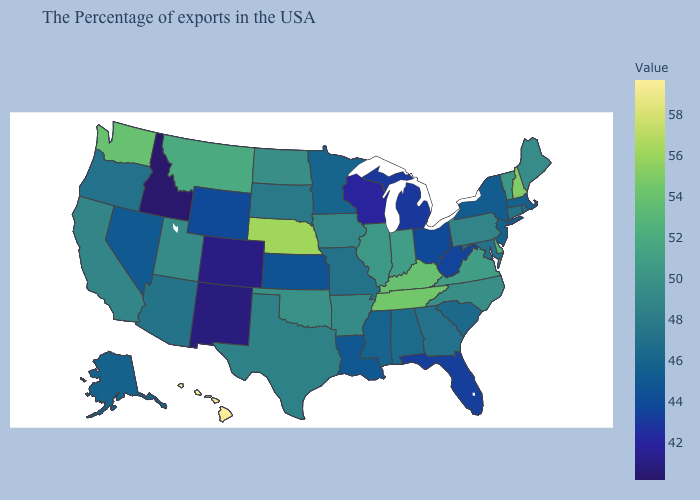Which states have the lowest value in the USA?
Concise answer only. Idaho. Among the states that border Alabama , does Tennessee have the highest value?
Be succinct. Yes. Among the states that border Colorado , which have the highest value?
Be succinct. Nebraska. Does Arizona have a higher value than Nevada?
Answer briefly. Yes. Is the legend a continuous bar?
Be succinct. Yes. Does New Hampshire have the highest value in the Northeast?
Quick response, please. Yes. Among the states that border California , which have the highest value?
Write a very short answer. Arizona. 